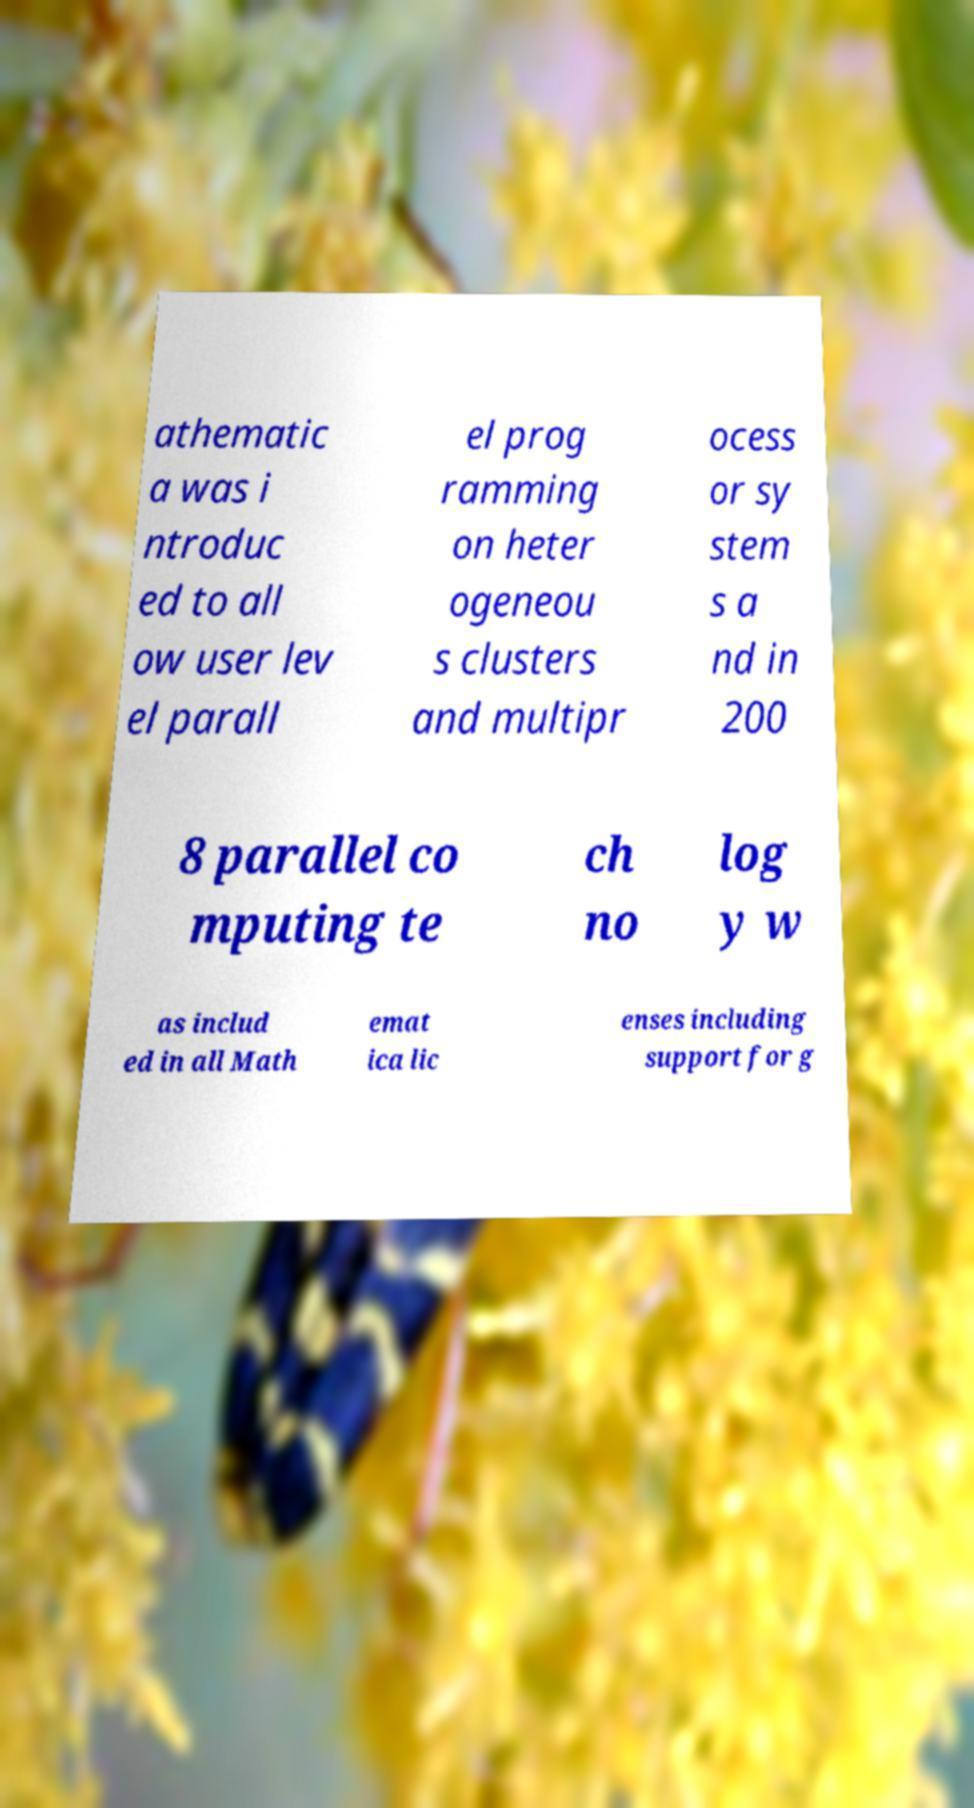Can you accurately transcribe the text from the provided image for me? athematic a was i ntroduc ed to all ow user lev el parall el prog ramming on heter ogeneou s clusters and multipr ocess or sy stem s a nd in 200 8 parallel co mputing te ch no log y w as includ ed in all Math emat ica lic enses including support for g 